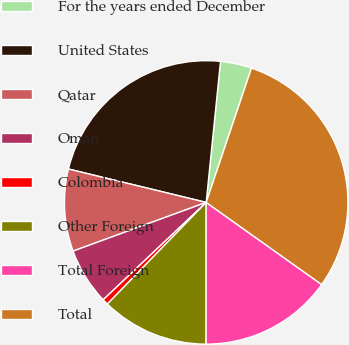Convert chart. <chart><loc_0><loc_0><loc_500><loc_500><pie_chart><fcel>For the years ended December<fcel>United States<fcel>Qatar<fcel>Oman<fcel>Colombia<fcel>Other Foreign<fcel>Total Foreign<fcel>Total<nl><fcel>3.57%<fcel>22.83%<fcel>9.37%<fcel>6.47%<fcel>0.67%<fcel>12.27%<fcel>15.17%<fcel>29.66%<nl></chart> 